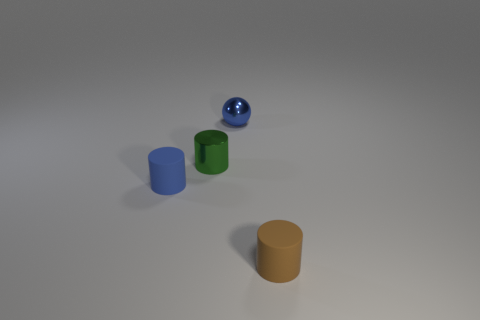Subtract all brown cylinders. How many cylinders are left? 2 Subtract all matte cylinders. How many cylinders are left? 1 Add 2 small cylinders. How many small cylinders exist? 5 Add 4 cylinders. How many objects exist? 8 Subtract 0 brown spheres. How many objects are left? 4 Subtract all balls. How many objects are left? 3 Subtract 1 spheres. How many spheres are left? 0 Subtract all gray cylinders. Subtract all brown balls. How many cylinders are left? 3 Subtract all brown spheres. How many gray cylinders are left? 0 Subtract all blue objects. Subtract all tiny brown matte objects. How many objects are left? 1 